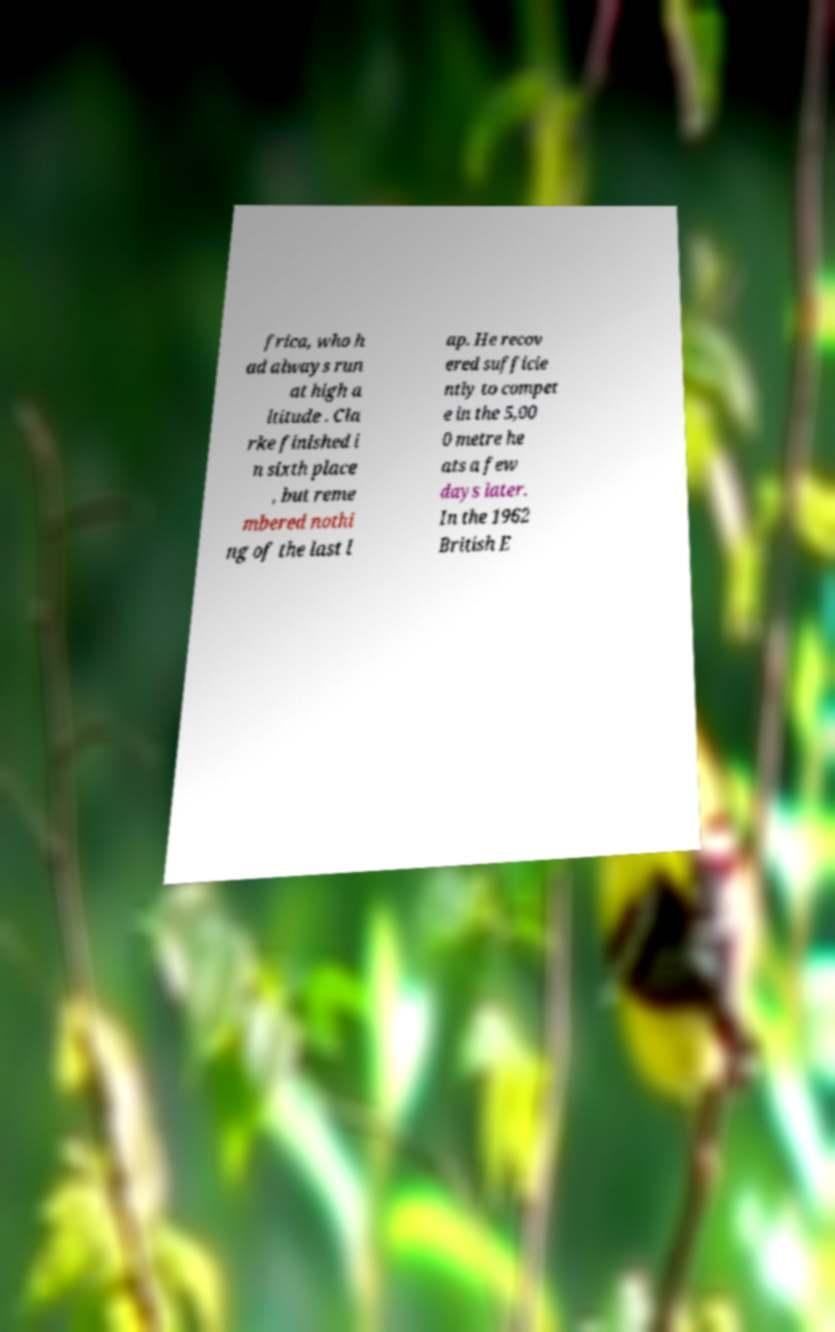Could you assist in decoding the text presented in this image and type it out clearly? frica, who h ad always run at high a ltitude . Cla rke finished i n sixth place , but reme mbered nothi ng of the last l ap. He recov ered sufficie ntly to compet e in the 5,00 0 metre he ats a few days later. In the 1962 British E 